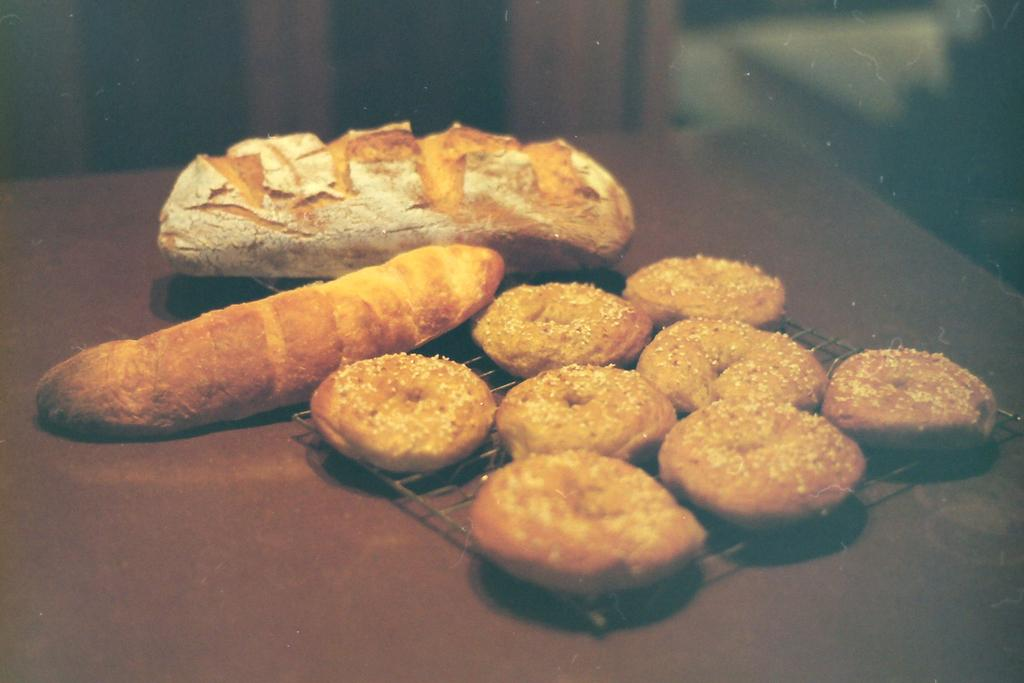What type of food items can be seen on the table in the image? There are cookies and bread on the table in the image. Can you describe the arrangement of the food items on the table? The provided facts do not give information about the arrangement of the food items on the table. What type of yak can be seen grazing near the table in the image? There is no yak present in the image; it only features cookies and bread on a table. How many light bulbs are visible on the table in the image? There is no mention of light bulbs in the provided facts, so we cannot determine if any are present in the image. 